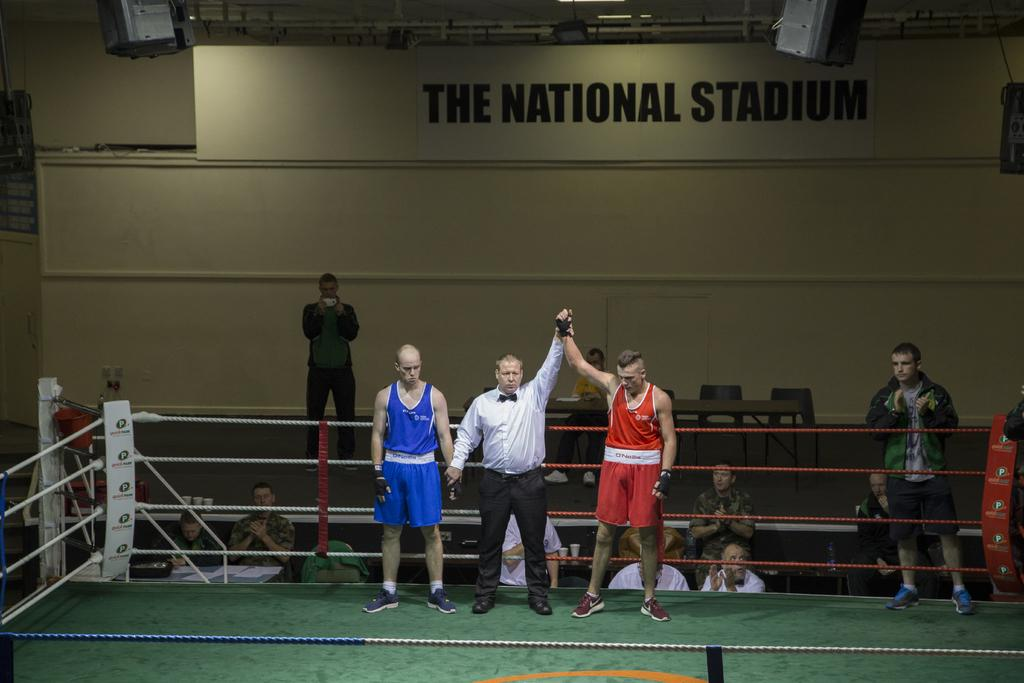Provide a one-sentence caption for the provided image. A winning boxer is declared at The National Stadium. 